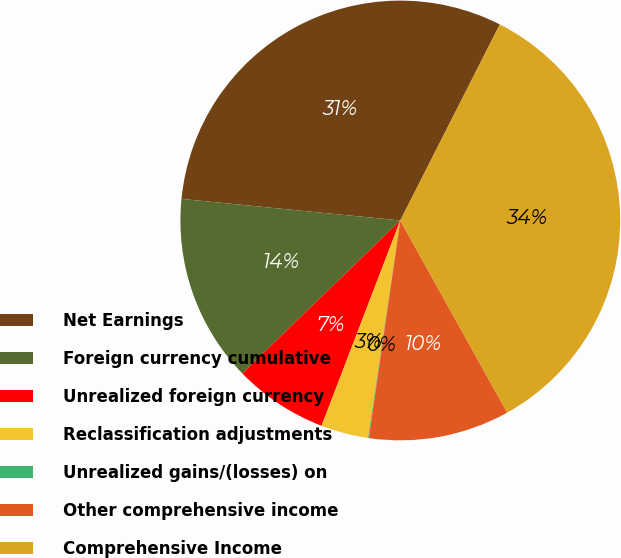Convert chart. <chart><loc_0><loc_0><loc_500><loc_500><pie_chart><fcel>Net Earnings<fcel>Foreign currency cumulative<fcel>Unrealized foreign currency<fcel>Reclassification adjustments<fcel>Unrealized gains/(losses) on<fcel>Other comprehensive income<fcel>Comprehensive Income<nl><fcel>30.91%<fcel>13.81%<fcel>6.93%<fcel>3.49%<fcel>0.05%<fcel>10.37%<fcel>34.44%<nl></chart> 